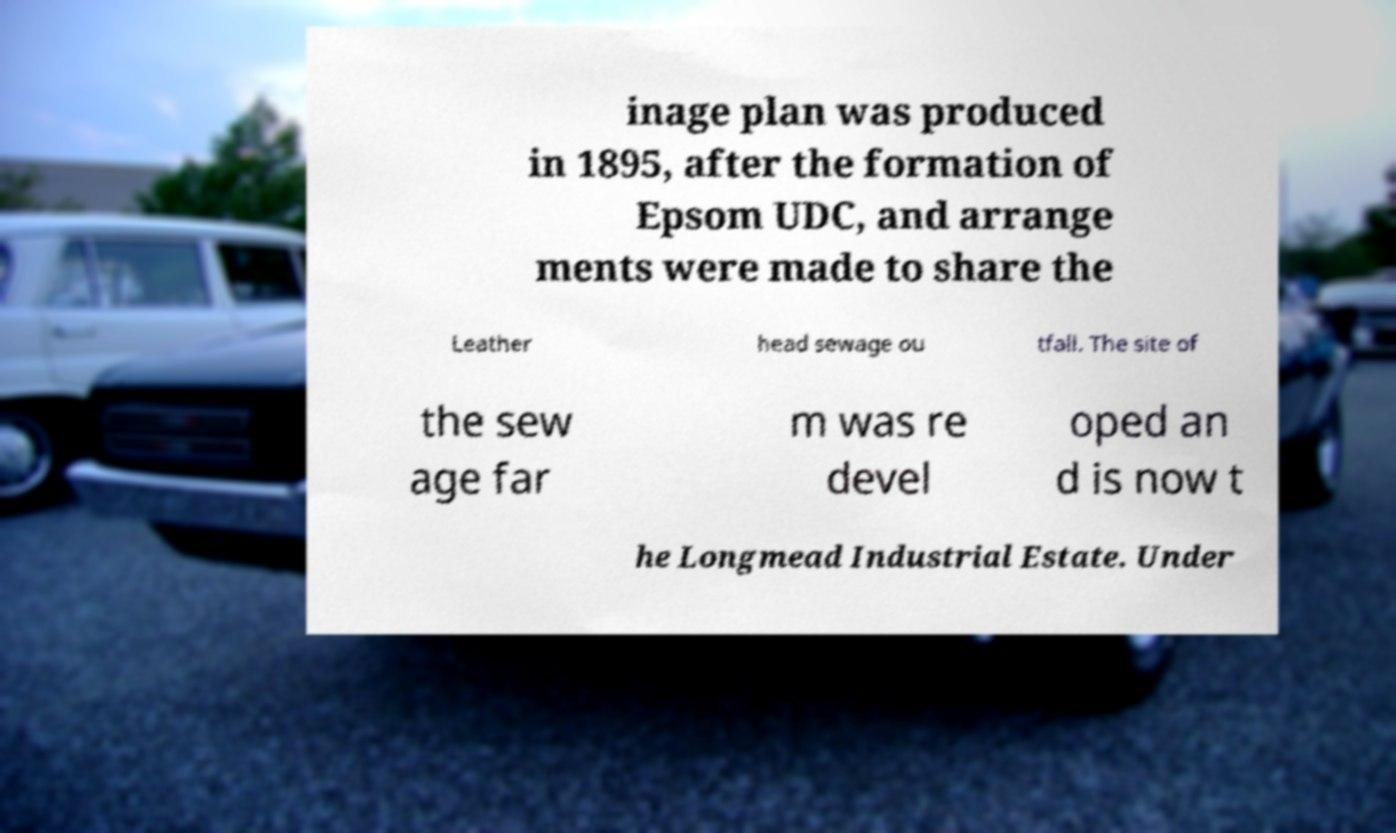Please read and relay the text visible in this image. What does it say? inage plan was produced in 1895, after the formation of Epsom UDC, and arrange ments were made to share the Leather head sewage ou tfall. The site of the sew age far m was re devel oped an d is now t he Longmead Industrial Estate. Under 